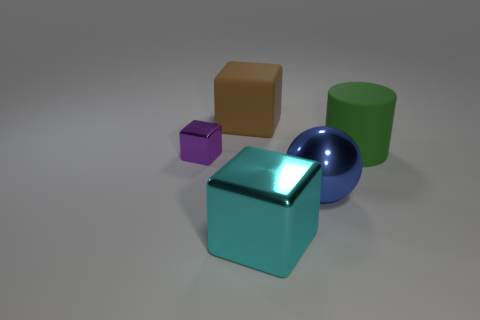How is the lighting affecting the appearance of the objects? The lighting in the image is soft and ambient, coming from above. It creates gentle shadows and subtle reflections on the objects, emphasizing their glossy textures and the three-dimensional aspect of their shapes. 